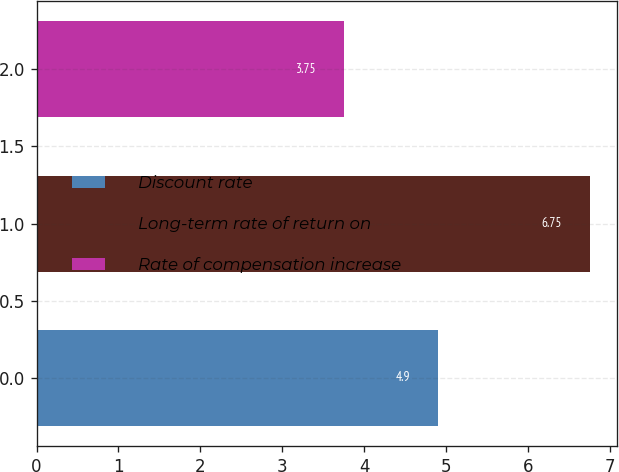Convert chart. <chart><loc_0><loc_0><loc_500><loc_500><bar_chart><fcel>Discount rate<fcel>Long-term rate of return on<fcel>Rate of compensation increase<nl><fcel>4.9<fcel>6.75<fcel>3.75<nl></chart> 